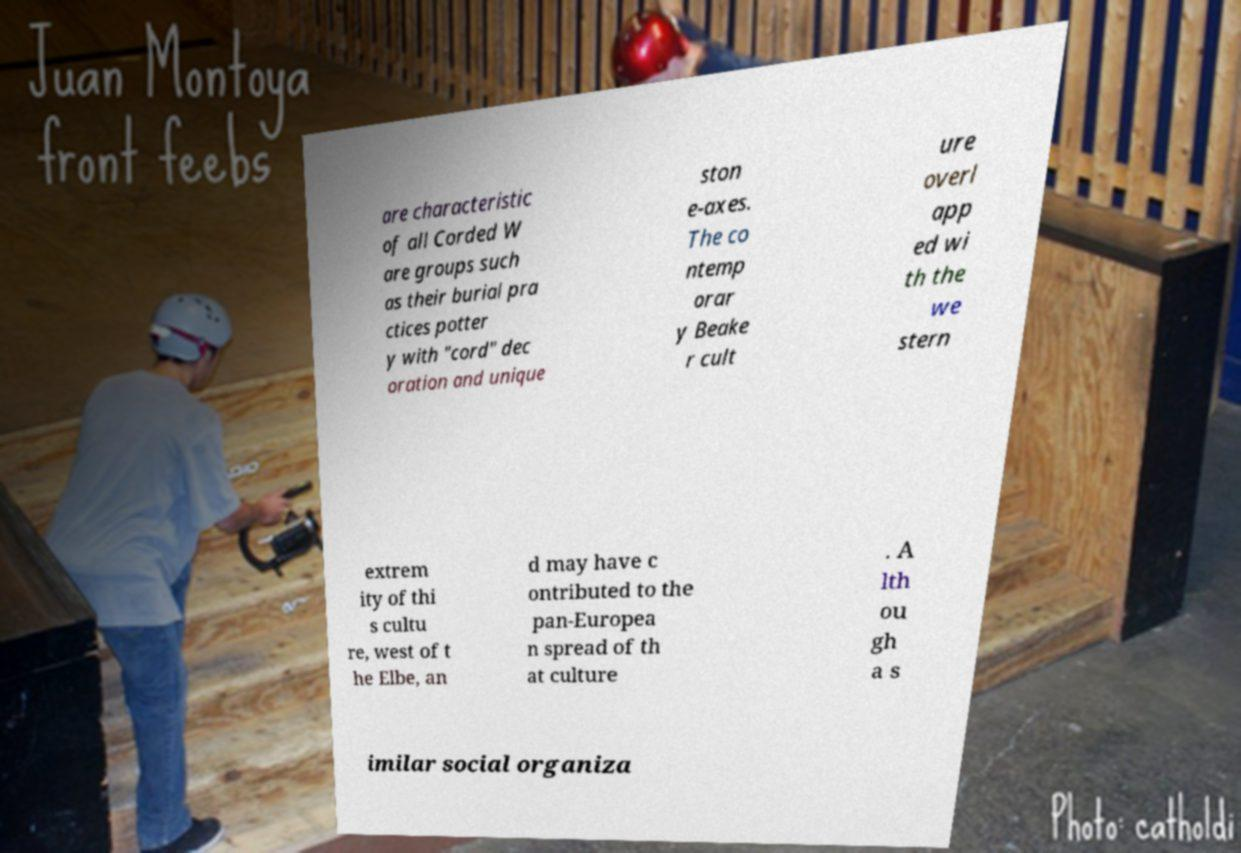I need the written content from this picture converted into text. Can you do that? are characteristic of all Corded W are groups such as their burial pra ctices potter y with "cord" dec oration and unique ston e-axes. The co ntemp orar y Beake r cult ure overl app ed wi th the we stern extrem ity of thi s cultu re, west of t he Elbe, an d may have c ontributed to the pan-Europea n spread of th at culture . A lth ou gh a s imilar social organiza 